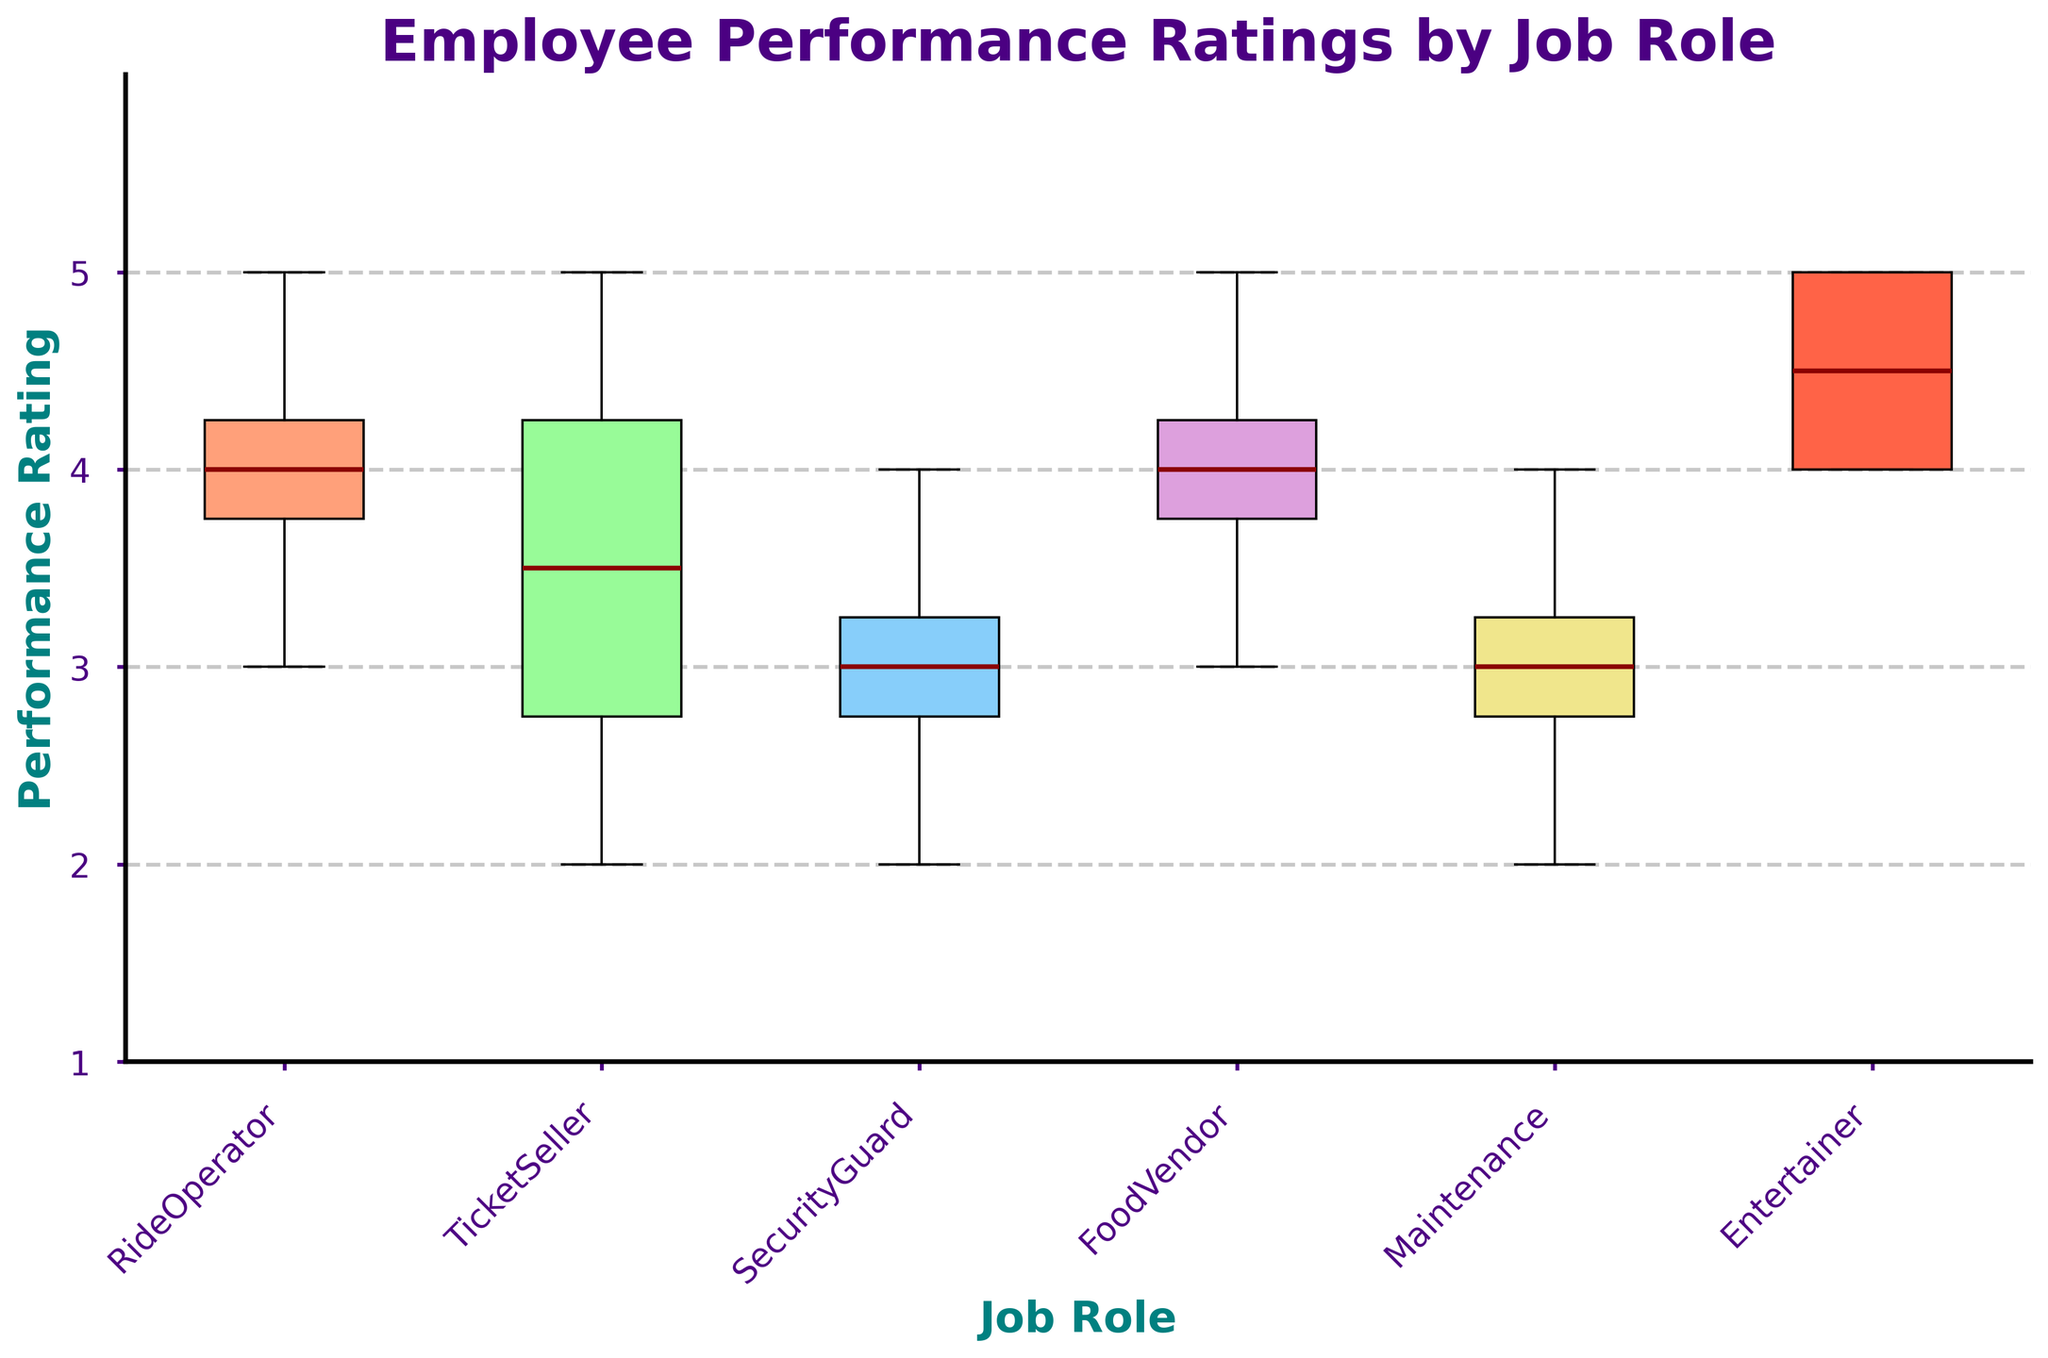What's the median performance rating for Ride Operators? The median is the middle value when the data is ordered. The Ride Operators' ratings are [3, 4, 4, 5]. The median value is the average of the two middle numbers (4+4)/2.
Answer: 4 Which job role has the lowest median performance rating? The median performance rating for each job role is as follows: Ride Operators (4), Ticket Sellers (3.5), Security Guards (3), Food Vendors (4), Maintenance (3), Entertainers (4.5). The lowest median is 3, which belongs to Security Guards and Maintenance.
Answer: Security Guards and Maintenance How many job roles have a median performance rating of 4 or higher? We inspect the medians from the box plot for each job role: Ride Operators (4), Ticket Sellers (3.5), Security Guards (3), Food Vendors (4), Maintenance (3), Entertainers (4.5). Three job roles meet the criterion.
Answer: 3 What is the interquartile range (IQR) for Ticket Sellers? The IQR is the difference between the third quartile (Q3) and the first quartile (Q1). For Ticket Sellers, Q1 is 3 and Q3 is 4. The IQR is 4 - 3.
Answer: 1 Which job role shows the greatest range in performance ratings? The range is the difference between the maximum and minimum values. By examining the box plot: Ride Operators (2), Ticket Sellers (3), Security Guards (2), Food Vendors (2), Maintenance (2), Entertainers (1). The greatest range is for Ticket Sellers.
Answer: Ticket Sellers Do Entertainers have the highest median performance rating? The median for Entertainers is 4.5. Comparing this to other job roles, no other job has a higher median.
Answer: Yes What is the performance rating variability (range) for Food Vendors? The range is the difference between the maximum and minimum values. For Food Vendors, the ratings are from 3 to 5, so the range is 5 - 3.
Answer: 2 Which job role has the minimum lower whisker value? The lower whisker represents the smallest observation within the 1.5 IQR range of the lower quartile. By looking at the box plot's whiskers for all job roles, the lowest whisker observed is for Maintenance (2).
Answer: Maintenance Which job role shows performance ratings skewed towards the higher end of the scale? Skewness can be identified by a longer upper whisker or a majority of values being closer to the higher end. For Entertainers, the median is closer to the upper quartile, and the upper whisker is longer.
Answer: Entertainers Is there any job role without outliers in their performance ratings? Outliers are usually depicted as individual points outside the whiskers. By inspecting the box plot, Entertainers, Food Vendors, and Maintenance show no outliers.
Answer: Yes 